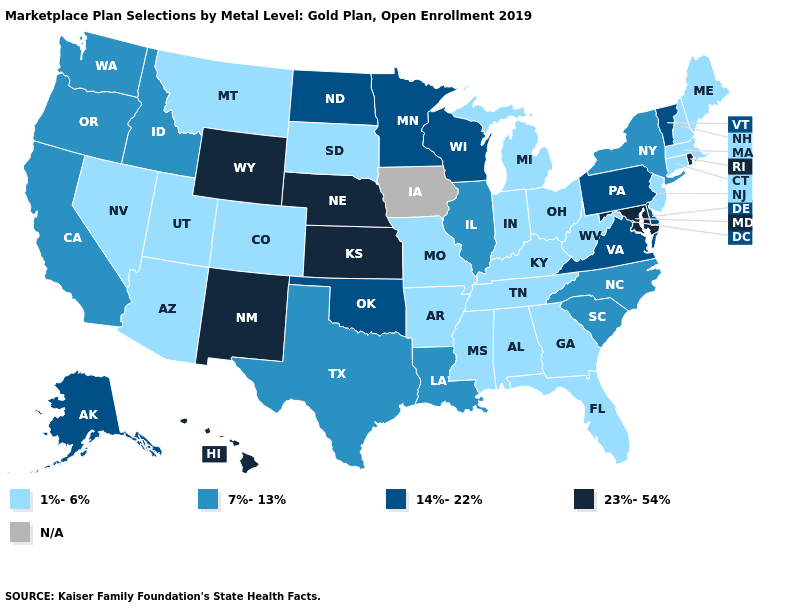Which states have the lowest value in the USA?
Write a very short answer. Alabama, Arizona, Arkansas, Colorado, Connecticut, Florida, Georgia, Indiana, Kentucky, Maine, Massachusetts, Michigan, Mississippi, Missouri, Montana, Nevada, New Hampshire, New Jersey, Ohio, South Dakota, Tennessee, Utah, West Virginia. Which states have the lowest value in the USA?
Answer briefly. Alabama, Arizona, Arkansas, Colorado, Connecticut, Florida, Georgia, Indiana, Kentucky, Maine, Massachusetts, Michigan, Mississippi, Missouri, Montana, Nevada, New Hampshire, New Jersey, Ohio, South Dakota, Tennessee, Utah, West Virginia. Name the states that have a value in the range 23%-54%?
Answer briefly. Hawaii, Kansas, Maryland, Nebraska, New Mexico, Rhode Island, Wyoming. What is the highest value in the USA?
Be succinct. 23%-54%. Does Wyoming have the highest value in the USA?
Concise answer only. Yes. Does New Jersey have the highest value in the USA?
Short answer required. No. What is the value of Minnesota?
Give a very brief answer. 14%-22%. Does Rhode Island have the lowest value in the Northeast?
Answer briefly. No. Which states have the lowest value in the USA?
Short answer required. Alabama, Arizona, Arkansas, Colorado, Connecticut, Florida, Georgia, Indiana, Kentucky, Maine, Massachusetts, Michigan, Mississippi, Missouri, Montana, Nevada, New Hampshire, New Jersey, Ohio, South Dakota, Tennessee, Utah, West Virginia. How many symbols are there in the legend?
Give a very brief answer. 5. Does Texas have the lowest value in the South?
Concise answer only. No. What is the value of Colorado?
Give a very brief answer. 1%-6%. Name the states that have a value in the range 7%-13%?
Write a very short answer. California, Idaho, Illinois, Louisiana, New York, North Carolina, Oregon, South Carolina, Texas, Washington. What is the value of Arizona?
Keep it brief. 1%-6%. 